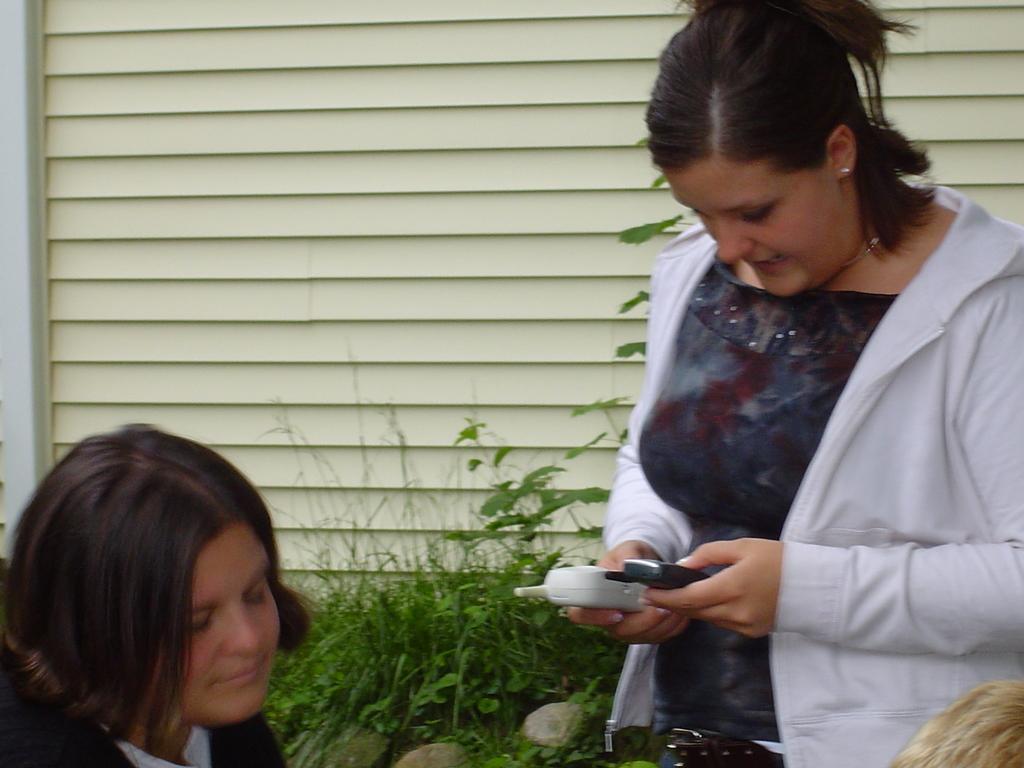Please provide a concise description of this image. In this image we can see this woman wearing sweater is standing and holding two mobile phones in her hand. Here we can see another person. In the background, we can see grass, stones and the window. 